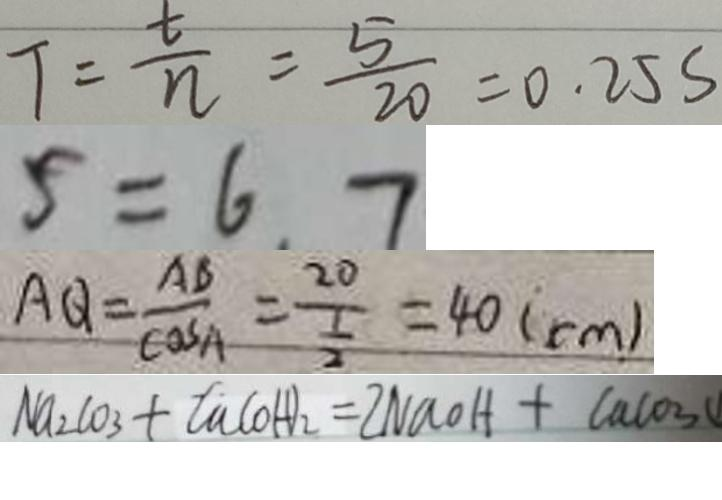Convert formula to latex. <formula><loc_0><loc_0><loc_500><loc_500>T = \frac { t } { n } = \frac { 5 } { 2 0 } = 0 . 2 5 s 
 5 = 6 . 7 
 A Q = \frac { A B } { \cos A } = \frac { 2 0 } { \frac { 1 } { 2 } } = 4 0 ( c m ) 
 N a _ { 2 } C O _ { 3 } + C a ( O H ) _ { 2 } = 2 N a O H + C a C O _ { 3 }</formula> 